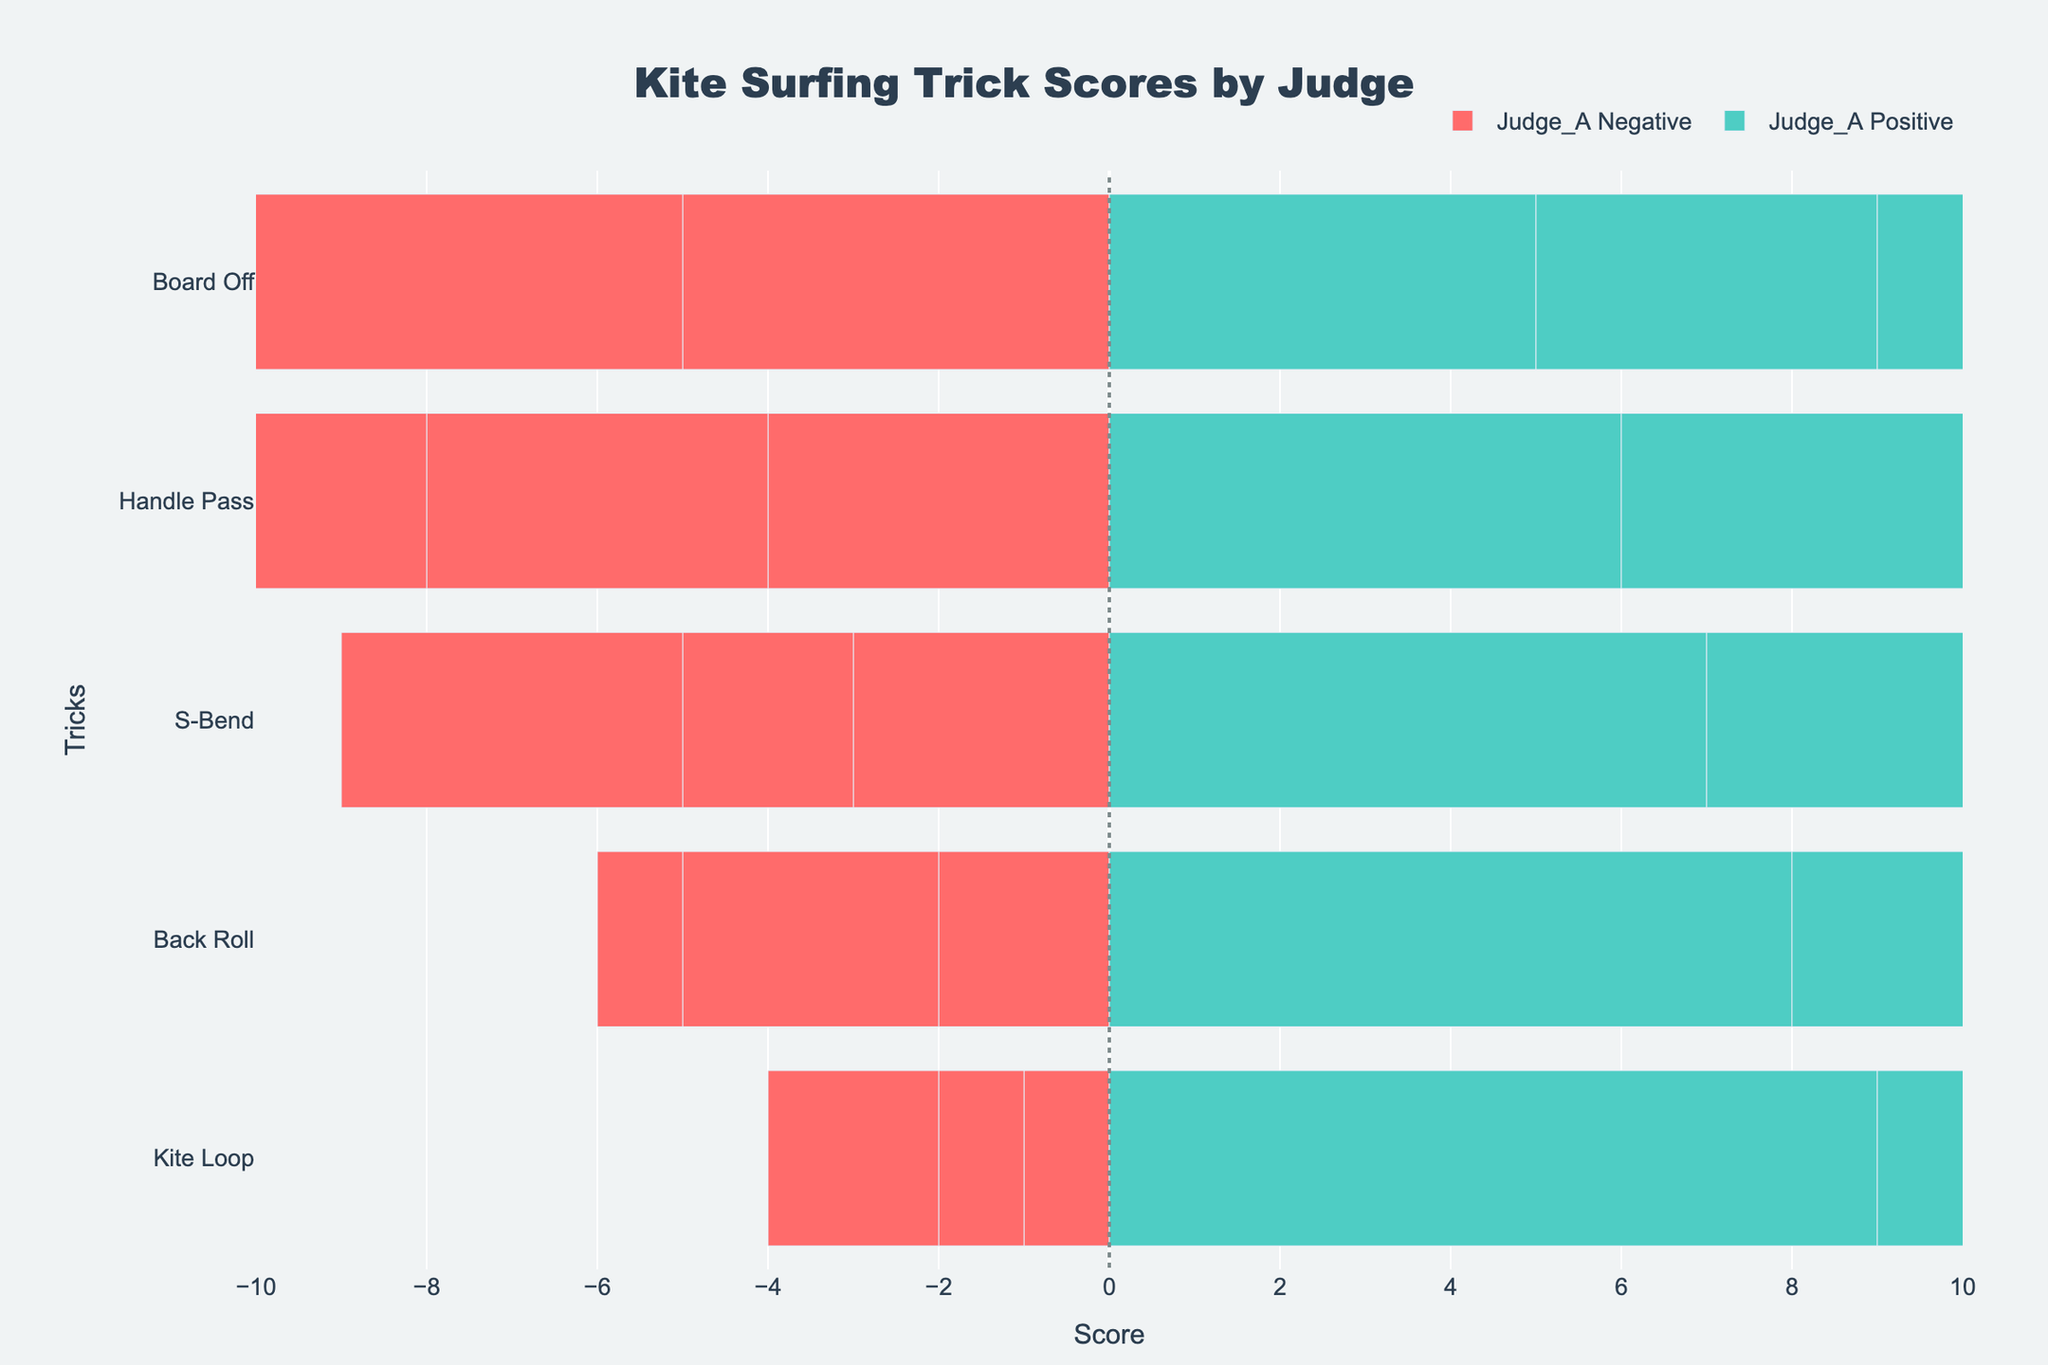What trick was rated highest by Judge B in terms of positive scores? Observe that Judge B gave the highest positive score of 9 to the trick "Kite Loop".
Answer: Kite Loop Which trick has the smallest difference in scores from Judge A? Calculate the difference between positive and negative scores for each trick rated by Judge A. The smallest difference is for "Board Off", where Positive = 5 and Negative = 5, leading to a difference of 0.
Answer: Board Off Which trick received the highest negative score from any judge? Check the negative scores across all judges and tricks. The highest negative score is 6, which is for "Board Off" given by Judge B.
Answer: Board Off What's the median positive score given by all judges for the trick "Handle Pass"? Collect all positive scores for "Handle Pass" across the judges: 6 (Judge A), 6 (Judge B), 5 (Judge C). Arrange them in order: 5, 6, 6. The median value is the middle one, which is 6.
Answer: 6 Which judge had the highest average positive score across all tricks? Calculate the average positive score for each judge: 
- Judge A: (8+7+9+6+5)/5 = 7 
- Judge B: (7+8+9+6+4)/5 = 6.8 
- Judge C: (9+6+8+5+7)/5 = 7
The highest average is 7, shared by Judge A and Judge C.
Answer: Judge A and Judge C Which trick was rated lowest by Judge C in terms of positive scores? Identify the lowest positive score given for each trick by Judge C. The lowest score is 5 for "Handle Pass".
Answer: Handle Pass Does Judge A generally give higher positive scores for Kite Loop compared to S-Bend? Compare the positive scores given by Judge A for "Kite Loop" (9) and "S-Bend" (7). "Kite Loop" has a higher score.
Answer: Yes What is the total score difference (positive minus negative) given to "Back Roll" by all judges combined? Calculate the total positive and negative scores for "Back Roll" across all judges: Positive: 8 (A) + 7 (B) + 9 (C) = 24, Negative: 2 (A) + 3 (B) + 1 (C) = 6. Difference: 24 - 6 = 18.
Answer: 18 Which tricks received an equal number of positive and negative scores from any judge? Find tricks where positive and negative scores are equal: "Board Off" from Judge A and "Handle Pass" from Judge C (both have Positive = Negative = 5).
Answer: Board Off (Judge A) and Handle Pass (Judge C) 